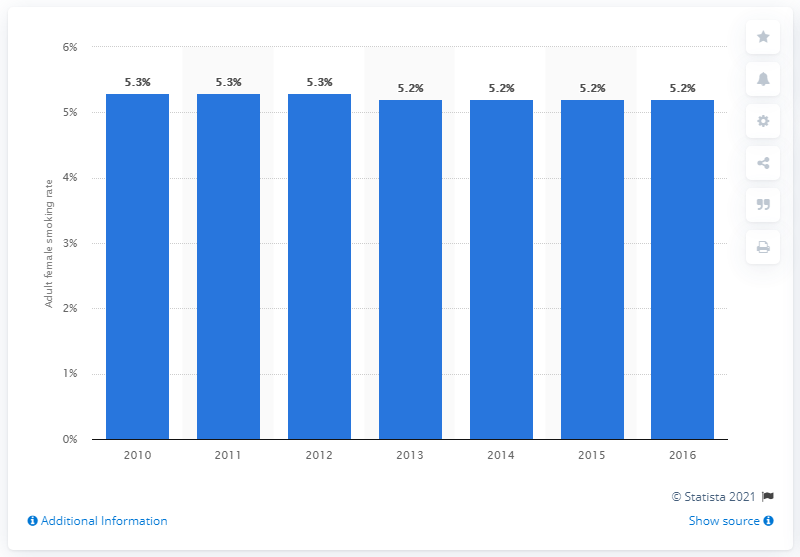Outline some significant characteristics in this image. The smoking prevalence rate for adult females in Singapore last changed in 2010. In 2016, the smoking prevalence rate among adult females in Singapore was 5.2%. 